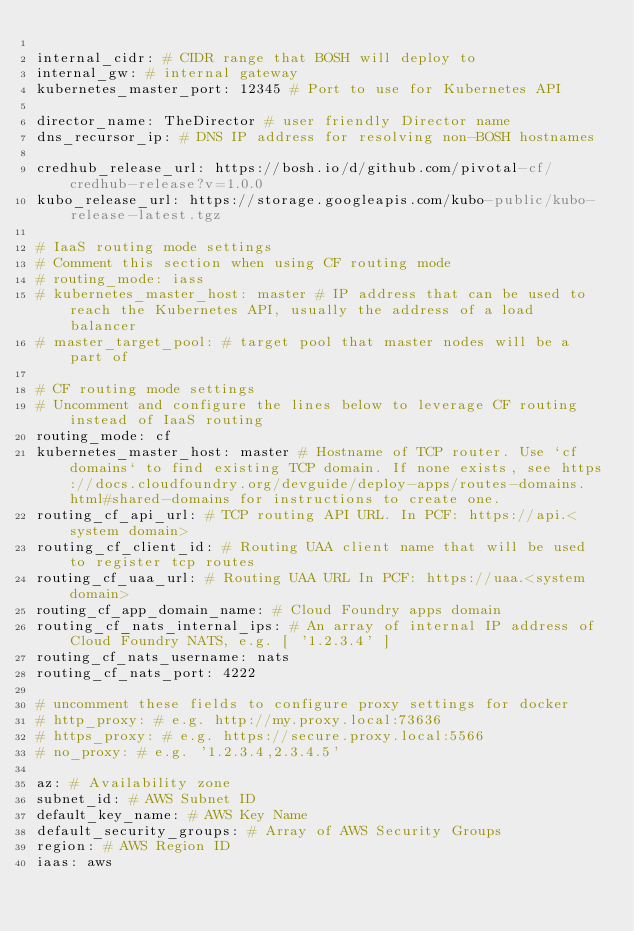<code> <loc_0><loc_0><loc_500><loc_500><_YAML_>
internal_cidr: # CIDR range that BOSH will deploy to
internal_gw: # internal gateway
kubernetes_master_port: 12345 # Port to use for Kubernetes API

director_name: TheDirector # user friendly Director name
dns_recursor_ip: # DNS IP address for resolving non-BOSH hostnames

credhub_release_url: https://bosh.io/d/github.com/pivotal-cf/credhub-release?v=1.0.0
kubo_release_url: https://storage.googleapis.com/kubo-public/kubo-release-latest.tgz

# IaaS routing mode settings
# Comment this section when using CF routing mode
# routing_mode: iass
# kubernetes_master_host: master # IP address that can be used to reach the Kubernetes API, usually the address of a load balancer
# master_target_pool: # target pool that master nodes will be a part of

# CF routing mode settings
# Uncomment and configure the lines below to leverage CF routing instead of IaaS routing
routing_mode: cf
kubernetes_master_host: master # Hostname of TCP router. Use `cf domains` to find existing TCP domain. If none exists, see https://docs.cloudfoundry.org/devguide/deploy-apps/routes-domains.html#shared-domains for instructions to create one.
routing_cf_api_url: # TCP routing API URL. In PCF: https://api.<system domain>
routing_cf_client_id: # Routing UAA client name that will be used to register tcp routes
routing_cf_uaa_url: # Routing UAA URL In PCF: https://uaa.<system domain>
routing_cf_app_domain_name: # Cloud Foundry apps domain
routing_cf_nats_internal_ips: # An array of internal IP address of Cloud Foundry NATS, e.g. [ '1.2.3.4' ]
routing_cf_nats_username: nats
routing_cf_nats_port: 4222

# uncomment these fields to configure proxy settings for docker
# http_proxy: # e.g. http://my.proxy.local:73636
# https_proxy: # e.g. https://secure.proxy.local:5566
# no_proxy: # e.g. '1.2.3.4,2.3.4.5'

az: # Availability zone
subnet_id: # AWS Subnet ID
default_key_name: # AWS Key Name
default_security_groups: # Array of AWS Security Groups
region: # AWS Region ID
iaas: aws
</code> 